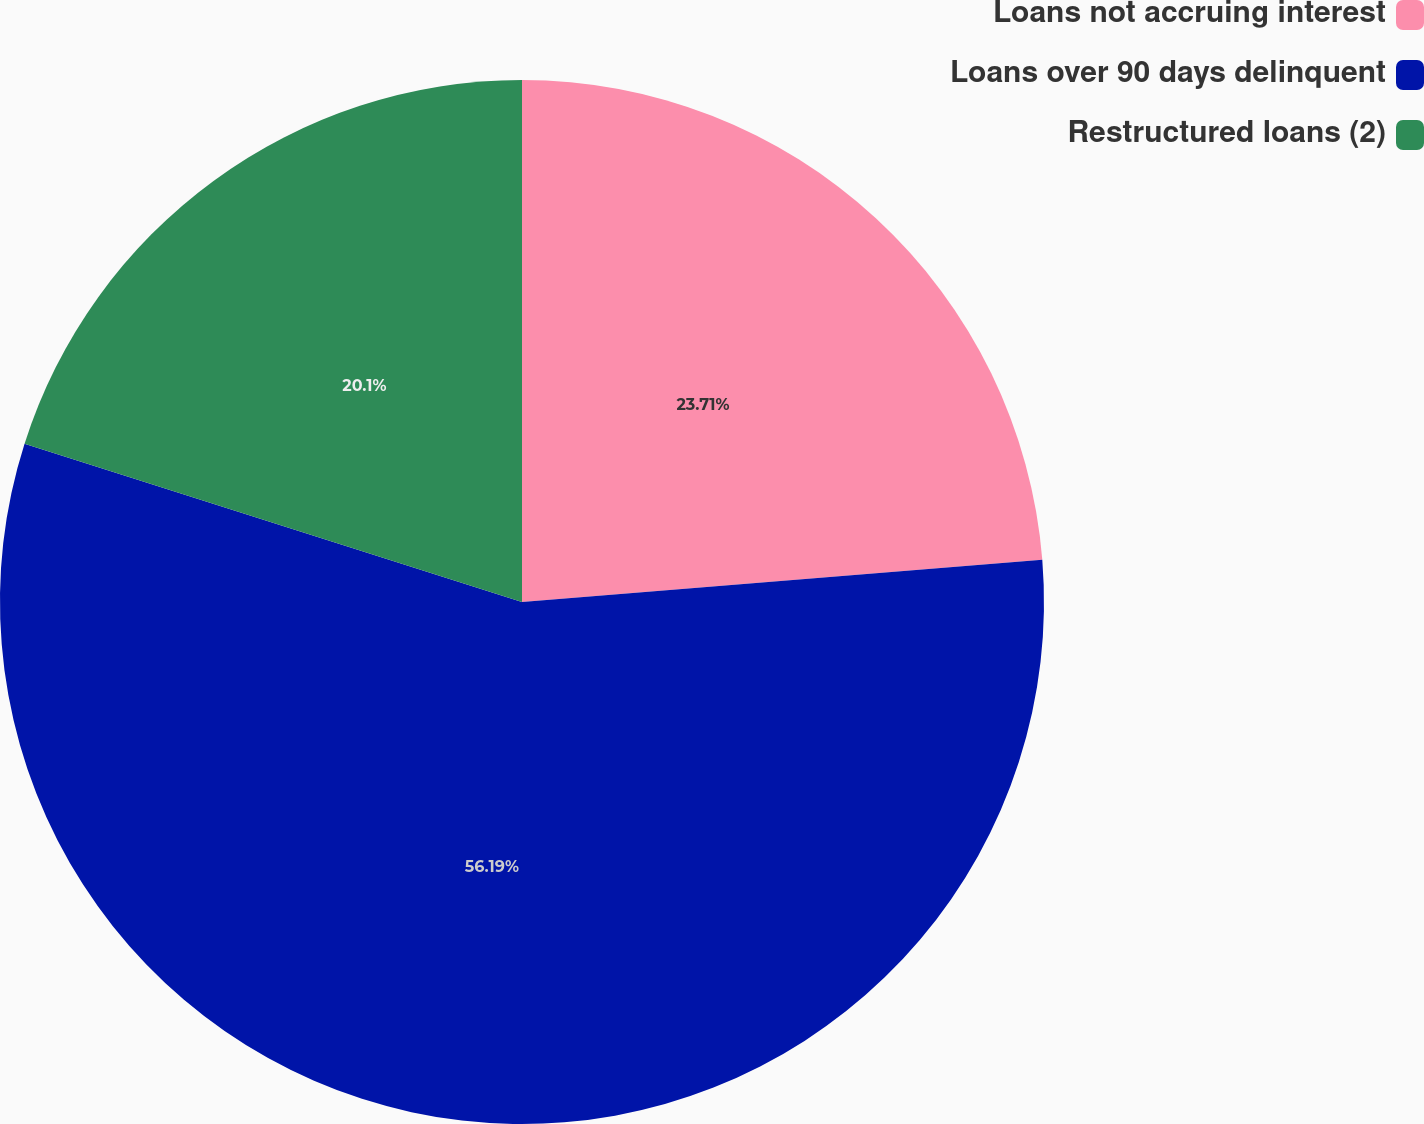<chart> <loc_0><loc_0><loc_500><loc_500><pie_chart><fcel>Loans not accruing interest<fcel>Loans over 90 days delinquent<fcel>Restructured loans (2)<nl><fcel>23.71%<fcel>56.19%<fcel>20.1%<nl></chart> 